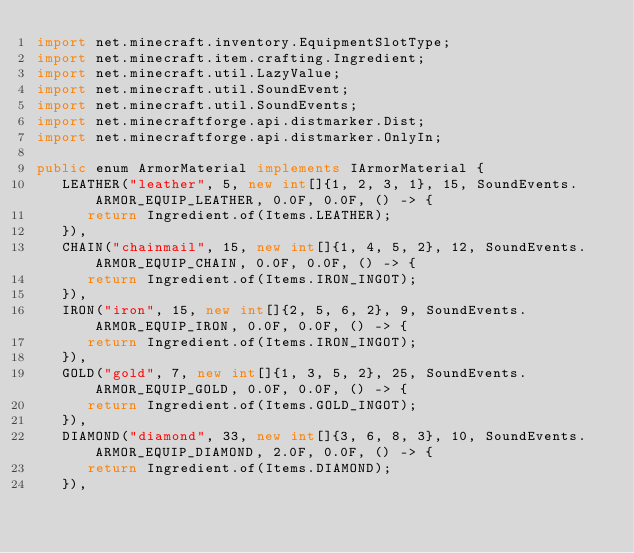<code> <loc_0><loc_0><loc_500><loc_500><_Java_>import net.minecraft.inventory.EquipmentSlotType;
import net.minecraft.item.crafting.Ingredient;
import net.minecraft.util.LazyValue;
import net.minecraft.util.SoundEvent;
import net.minecraft.util.SoundEvents;
import net.minecraftforge.api.distmarker.Dist;
import net.minecraftforge.api.distmarker.OnlyIn;

public enum ArmorMaterial implements IArmorMaterial {
   LEATHER("leather", 5, new int[]{1, 2, 3, 1}, 15, SoundEvents.ARMOR_EQUIP_LEATHER, 0.0F, 0.0F, () -> {
      return Ingredient.of(Items.LEATHER);
   }),
   CHAIN("chainmail", 15, new int[]{1, 4, 5, 2}, 12, SoundEvents.ARMOR_EQUIP_CHAIN, 0.0F, 0.0F, () -> {
      return Ingredient.of(Items.IRON_INGOT);
   }),
   IRON("iron", 15, new int[]{2, 5, 6, 2}, 9, SoundEvents.ARMOR_EQUIP_IRON, 0.0F, 0.0F, () -> {
      return Ingredient.of(Items.IRON_INGOT);
   }),
   GOLD("gold", 7, new int[]{1, 3, 5, 2}, 25, SoundEvents.ARMOR_EQUIP_GOLD, 0.0F, 0.0F, () -> {
      return Ingredient.of(Items.GOLD_INGOT);
   }),
   DIAMOND("diamond", 33, new int[]{3, 6, 8, 3}, 10, SoundEvents.ARMOR_EQUIP_DIAMOND, 2.0F, 0.0F, () -> {
      return Ingredient.of(Items.DIAMOND);
   }),</code> 